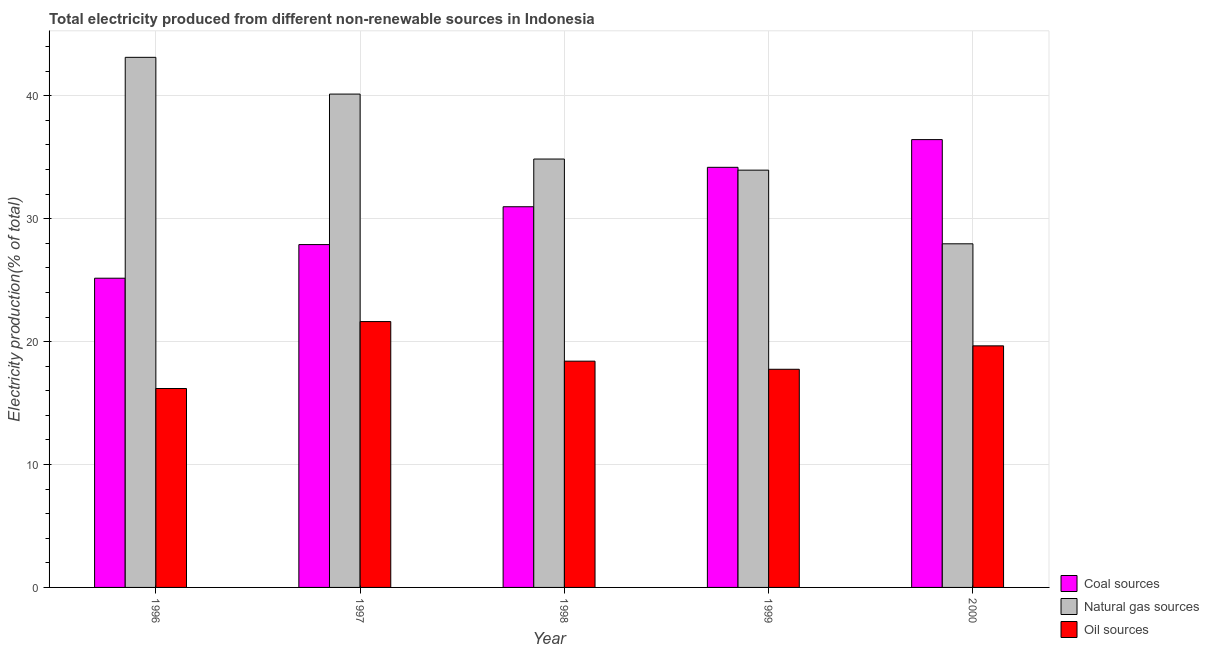Are the number of bars on each tick of the X-axis equal?
Make the answer very short. Yes. How many bars are there on the 1st tick from the right?
Offer a very short reply. 3. What is the percentage of electricity produced by oil sources in 1996?
Your response must be concise. 16.18. Across all years, what is the maximum percentage of electricity produced by natural gas?
Your answer should be very brief. 43.13. Across all years, what is the minimum percentage of electricity produced by oil sources?
Your response must be concise. 16.18. In which year was the percentage of electricity produced by coal maximum?
Your answer should be very brief. 2000. What is the total percentage of electricity produced by coal in the graph?
Give a very brief answer. 154.64. What is the difference between the percentage of electricity produced by natural gas in 1996 and that in 1997?
Provide a short and direct response. 2.99. What is the difference between the percentage of electricity produced by coal in 1999 and the percentage of electricity produced by natural gas in 1996?
Give a very brief answer. 9.02. What is the average percentage of electricity produced by coal per year?
Provide a short and direct response. 30.93. What is the ratio of the percentage of electricity produced by oil sources in 1996 to that in 1998?
Offer a terse response. 0.88. Is the percentage of electricity produced by natural gas in 1997 less than that in 1999?
Offer a very short reply. No. Is the difference between the percentage of electricity produced by oil sources in 1996 and 2000 greater than the difference between the percentage of electricity produced by natural gas in 1996 and 2000?
Provide a short and direct response. No. What is the difference between the highest and the second highest percentage of electricity produced by coal?
Ensure brevity in your answer.  2.25. What is the difference between the highest and the lowest percentage of electricity produced by coal?
Keep it short and to the point. 11.28. What does the 2nd bar from the left in 2000 represents?
Ensure brevity in your answer.  Natural gas sources. What does the 3rd bar from the right in 2000 represents?
Provide a succinct answer. Coal sources. Is it the case that in every year, the sum of the percentage of electricity produced by coal and percentage of electricity produced by natural gas is greater than the percentage of electricity produced by oil sources?
Ensure brevity in your answer.  Yes. Are all the bars in the graph horizontal?
Your answer should be very brief. No. How many years are there in the graph?
Give a very brief answer. 5. What is the difference between two consecutive major ticks on the Y-axis?
Give a very brief answer. 10. Are the values on the major ticks of Y-axis written in scientific E-notation?
Give a very brief answer. No. Does the graph contain grids?
Provide a succinct answer. Yes. What is the title of the graph?
Offer a terse response. Total electricity produced from different non-renewable sources in Indonesia. Does "Other sectors" appear as one of the legend labels in the graph?
Offer a terse response. No. What is the Electricity production(% of total) in Coal sources in 1996?
Your answer should be compact. 25.16. What is the Electricity production(% of total) of Natural gas sources in 1996?
Provide a succinct answer. 43.13. What is the Electricity production(% of total) in Oil sources in 1996?
Offer a very short reply. 16.18. What is the Electricity production(% of total) of Coal sources in 1997?
Keep it short and to the point. 27.89. What is the Electricity production(% of total) in Natural gas sources in 1997?
Give a very brief answer. 40.14. What is the Electricity production(% of total) of Oil sources in 1997?
Ensure brevity in your answer.  21.63. What is the Electricity production(% of total) of Coal sources in 1998?
Ensure brevity in your answer.  30.97. What is the Electricity production(% of total) in Natural gas sources in 1998?
Your answer should be compact. 34.85. What is the Electricity production(% of total) of Oil sources in 1998?
Your response must be concise. 18.41. What is the Electricity production(% of total) in Coal sources in 1999?
Your response must be concise. 34.18. What is the Electricity production(% of total) of Natural gas sources in 1999?
Offer a terse response. 33.95. What is the Electricity production(% of total) in Oil sources in 1999?
Your response must be concise. 17.75. What is the Electricity production(% of total) of Coal sources in 2000?
Offer a terse response. 36.43. What is the Electricity production(% of total) of Natural gas sources in 2000?
Make the answer very short. 27.96. What is the Electricity production(% of total) in Oil sources in 2000?
Your response must be concise. 19.65. Across all years, what is the maximum Electricity production(% of total) of Coal sources?
Provide a succinct answer. 36.43. Across all years, what is the maximum Electricity production(% of total) in Natural gas sources?
Offer a terse response. 43.13. Across all years, what is the maximum Electricity production(% of total) in Oil sources?
Keep it short and to the point. 21.63. Across all years, what is the minimum Electricity production(% of total) in Coal sources?
Offer a terse response. 25.16. Across all years, what is the minimum Electricity production(% of total) in Natural gas sources?
Ensure brevity in your answer.  27.96. Across all years, what is the minimum Electricity production(% of total) of Oil sources?
Provide a succinct answer. 16.18. What is the total Electricity production(% of total) of Coal sources in the graph?
Give a very brief answer. 154.64. What is the total Electricity production(% of total) of Natural gas sources in the graph?
Give a very brief answer. 180.02. What is the total Electricity production(% of total) of Oil sources in the graph?
Ensure brevity in your answer.  93.63. What is the difference between the Electricity production(% of total) of Coal sources in 1996 and that in 1997?
Provide a short and direct response. -2.74. What is the difference between the Electricity production(% of total) of Natural gas sources in 1996 and that in 1997?
Give a very brief answer. 2.99. What is the difference between the Electricity production(% of total) in Oil sources in 1996 and that in 1997?
Make the answer very short. -5.45. What is the difference between the Electricity production(% of total) in Coal sources in 1996 and that in 1998?
Keep it short and to the point. -5.81. What is the difference between the Electricity production(% of total) of Natural gas sources in 1996 and that in 1998?
Provide a succinct answer. 8.27. What is the difference between the Electricity production(% of total) in Oil sources in 1996 and that in 1998?
Give a very brief answer. -2.23. What is the difference between the Electricity production(% of total) in Coal sources in 1996 and that in 1999?
Ensure brevity in your answer.  -9.02. What is the difference between the Electricity production(% of total) in Natural gas sources in 1996 and that in 1999?
Your response must be concise. 9.18. What is the difference between the Electricity production(% of total) in Oil sources in 1996 and that in 1999?
Your answer should be compact. -1.57. What is the difference between the Electricity production(% of total) of Coal sources in 1996 and that in 2000?
Your answer should be very brief. -11.28. What is the difference between the Electricity production(% of total) in Natural gas sources in 1996 and that in 2000?
Your response must be concise. 15.17. What is the difference between the Electricity production(% of total) of Oil sources in 1996 and that in 2000?
Make the answer very short. -3.47. What is the difference between the Electricity production(% of total) of Coal sources in 1997 and that in 1998?
Make the answer very short. -3.08. What is the difference between the Electricity production(% of total) in Natural gas sources in 1997 and that in 1998?
Keep it short and to the point. 5.28. What is the difference between the Electricity production(% of total) of Oil sources in 1997 and that in 1998?
Your answer should be very brief. 3.22. What is the difference between the Electricity production(% of total) in Coal sources in 1997 and that in 1999?
Keep it short and to the point. -6.29. What is the difference between the Electricity production(% of total) in Natural gas sources in 1997 and that in 1999?
Provide a short and direct response. 6.19. What is the difference between the Electricity production(% of total) in Oil sources in 1997 and that in 1999?
Your answer should be very brief. 3.88. What is the difference between the Electricity production(% of total) of Coal sources in 1997 and that in 2000?
Keep it short and to the point. -8.54. What is the difference between the Electricity production(% of total) of Natural gas sources in 1997 and that in 2000?
Make the answer very short. 12.18. What is the difference between the Electricity production(% of total) of Oil sources in 1997 and that in 2000?
Ensure brevity in your answer.  1.98. What is the difference between the Electricity production(% of total) of Coal sources in 1998 and that in 1999?
Your answer should be compact. -3.21. What is the difference between the Electricity production(% of total) in Natural gas sources in 1998 and that in 1999?
Ensure brevity in your answer.  0.9. What is the difference between the Electricity production(% of total) in Oil sources in 1998 and that in 1999?
Your answer should be very brief. 0.66. What is the difference between the Electricity production(% of total) in Coal sources in 1998 and that in 2000?
Provide a short and direct response. -5.46. What is the difference between the Electricity production(% of total) in Natural gas sources in 1998 and that in 2000?
Provide a short and direct response. 6.9. What is the difference between the Electricity production(% of total) in Oil sources in 1998 and that in 2000?
Your response must be concise. -1.24. What is the difference between the Electricity production(% of total) of Coal sources in 1999 and that in 2000?
Provide a short and direct response. -2.25. What is the difference between the Electricity production(% of total) of Natural gas sources in 1999 and that in 2000?
Your answer should be very brief. 5.99. What is the difference between the Electricity production(% of total) of Oil sources in 1999 and that in 2000?
Give a very brief answer. -1.91. What is the difference between the Electricity production(% of total) in Coal sources in 1996 and the Electricity production(% of total) in Natural gas sources in 1997?
Provide a succinct answer. -14.98. What is the difference between the Electricity production(% of total) in Coal sources in 1996 and the Electricity production(% of total) in Oil sources in 1997?
Offer a very short reply. 3.53. What is the difference between the Electricity production(% of total) of Natural gas sources in 1996 and the Electricity production(% of total) of Oil sources in 1997?
Provide a succinct answer. 21.5. What is the difference between the Electricity production(% of total) in Coal sources in 1996 and the Electricity production(% of total) in Natural gas sources in 1998?
Provide a short and direct response. -9.7. What is the difference between the Electricity production(% of total) of Coal sources in 1996 and the Electricity production(% of total) of Oil sources in 1998?
Your response must be concise. 6.75. What is the difference between the Electricity production(% of total) of Natural gas sources in 1996 and the Electricity production(% of total) of Oil sources in 1998?
Provide a short and direct response. 24.72. What is the difference between the Electricity production(% of total) of Coal sources in 1996 and the Electricity production(% of total) of Natural gas sources in 1999?
Your answer should be very brief. -8.79. What is the difference between the Electricity production(% of total) in Coal sources in 1996 and the Electricity production(% of total) in Oil sources in 1999?
Your answer should be compact. 7.41. What is the difference between the Electricity production(% of total) of Natural gas sources in 1996 and the Electricity production(% of total) of Oil sources in 1999?
Give a very brief answer. 25.38. What is the difference between the Electricity production(% of total) of Coal sources in 1996 and the Electricity production(% of total) of Natural gas sources in 2000?
Make the answer very short. -2.8. What is the difference between the Electricity production(% of total) of Coal sources in 1996 and the Electricity production(% of total) of Oil sources in 2000?
Provide a succinct answer. 5.5. What is the difference between the Electricity production(% of total) in Natural gas sources in 1996 and the Electricity production(% of total) in Oil sources in 2000?
Provide a succinct answer. 23.47. What is the difference between the Electricity production(% of total) in Coal sources in 1997 and the Electricity production(% of total) in Natural gas sources in 1998?
Keep it short and to the point. -6.96. What is the difference between the Electricity production(% of total) in Coal sources in 1997 and the Electricity production(% of total) in Oil sources in 1998?
Provide a succinct answer. 9.48. What is the difference between the Electricity production(% of total) in Natural gas sources in 1997 and the Electricity production(% of total) in Oil sources in 1998?
Your answer should be very brief. 21.73. What is the difference between the Electricity production(% of total) in Coal sources in 1997 and the Electricity production(% of total) in Natural gas sources in 1999?
Your response must be concise. -6.06. What is the difference between the Electricity production(% of total) in Coal sources in 1997 and the Electricity production(% of total) in Oil sources in 1999?
Your answer should be compact. 10.14. What is the difference between the Electricity production(% of total) of Natural gas sources in 1997 and the Electricity production(% of total) of Oil sources in 1999?
Ensure brevity in your answer.  22.39. What is the difference between the Electricity production(% of total) in Coal sources in 1997 and the Electricity production(% of total) in Natural gas sources in 2000?
Your answer should be compact. -0.06. What is the difference between the Electricity production(% of total) in Coal sources in 1997 and the Electricity production(% of total) in Oil sources in 2000?
Make the answer very short. 8.24. What is the difference between the Electricity production(% of total) of Natural gas sources in 1997 and the Electricity production(% of total) of Oil sources in 2000?
Provide a short and direct response. 20.48. What is the difference between the Electricity production(% of total) of Coal sources in 1998 and the Electricity production(% of total) of Natural gas sources in 1999?
Provide a short and direct response. -2.98. What is the difference between the Electricity production(% of total) of Coal sources in 1998 and the Electricity production(% of total) of Oil sources in 1999?
Give a very brief answer. 13.22. What is the difference between the Electricity production(% of total) in Natural gas sources in 1998 and the Electricity production(% of total) in Oil sources in 1999?
Ensure brevity in your answer.  17.1. What is the difference between the Electricity production(% of total) in Coal sources in 1998 and the Electricity production(% of total) in Natural gas sources in 2000?
Ensure brevity in your answer.  3.02. What is the difference between the Electricity production(% of total) of Coal sources in 1998 and the Electricity production(% of total) of Oil sources in 2000?
Offer a very short reply. 11.32. What is the difference between the Electricity production(% of total) of Natural gas sources in 1998 and the Electricity production(% of total) of Oil sources in 2000?
Give a very brief answer. 15.2. What is the difference between the Electricity production(% of total) of Coal sources in 1999 and the Electricity production(% of total) of Natural gas sources in 2000?
Make the answer very short. 6.22. What is the difference between the Electricity production(% of total) in Coal sources in 1999 and the Electricity production(% of total) in Oil sources in 2000?
Your answer should be compact. 14.53. What is the difference between the Electricity production(% of total) of Natural gas sources in 1999 and the Electricity production(% of total) of Oil sources in 2000?
Your answer should be compact. 14.29. What is the average Electricity production(% of total) in Coal sources per year?
Offer a terse response. 30.93. What is the average Electricity production(% of total) of Natural gas sources per year?
Ensure brevity in your answer.  36. What is the average Electricity production(% of total) in Oil sources per year?
Provide a short and direct response. 18.73. In the year 1996, what is the difference between the Electricity production(% of total) of Coal sources and Electricity production(% of total) of Natural gas sources?
Your answer should be very brief. -17.97. In the year 1996, what is the difference between the Electricity production(% of total) in Coal sources and Electricity production(% of total) in Oil sources?
Give a very brief answer. 8.97. In the year 1996, what is the difference between the Electricity production(% of total) of Natural gas sources and Electricity production(% of total) of Oil sources?
Provide a short and direct response. 26.94. In the year 1997, what is the difference between the Electricity production(% of total) in Coal sources and Electricity production(% of total) in Natural gas sources?
Provide a short and direct response. -12.24. In the year 1997, what is the difference between the Electricity production(% of total) of Coal sources and Electricity production(% of total) of Oil sources?
Give a very brief answer. 6.26. In the year 1997, what is the difference between the Electricity production(% of total) in Natural gas sources and Electricity production(% of total) in Oil sources?
Ensure brevity in your answer.  18.51. In the year 1998, what is the difference between the Electricity production(% of total) in Coal sources and Electricity production(% of total) in Natural gas sources?
Give a very brief answer. -3.88. In the year 1998, what is the difference between the Electricity production(% of total) in Coal sources and Electricity production(% of total) in Oil sources?
Give a very brief answer. 12.56. In the year 1998, what is the difference between the Electricity production(% of total) in Natural gas sources and Electricity production(% of total) in Oil sources?
Provide a succinct answer. 16.44. In the year 1999, what is the difference between the Electricity production(% of total) of Coal sources and Electricity production(% of total) of Natural gas sources?
Provide a short and direct response. 0.23. In the year 1999, what is the difference between the Electricity production(% of total) of Coal sources and Electricity production(% of total) of Oil sources?
Provide a short and direct response. 16.43. In the year 1999, what is the difference between the Electricity production(% of total) of Natural gas sources and Electricity production(% of total) of Oil sources?
Provide a succinct answer. 16.2. In the year 2000, what is the difference between the Electricity production(% of total) in Coal sources and Electricity production(% of total) in Natural gas sources?
Provide a short and direct response. 8.48. In the year 2000, what is the difference between the Electricity production(% of total) in Coal sources and Electricity production(% of total) in Oil sources?
Ensure brevity in your answer.  16.78. In the year 2000, what is the difference between the Electricity production(% of total) of Natural gas sources and Electricity production(% of total) of Oil sources?
Offer a very short reply. 8.3. What is the ratio of the Electricity production(% of total) of Coal sources in 1996 to that in 1997?
Your answer should be very brief. 0.9. What is the ratio of the Electricity production(% of total) in Natural gas sources in 1996 to that in 1997?
Ensure brevity in your answer.  1.07. What is the ratio of the Electricity production(% of total) in Oil sources in 1996 to that in 1997?
Give a very brief answer. 0.75. What is the ratio of the Electricity production(% of total) of Coal sources in 1996 to that in 1998?
Keep it short and to the point. 0.81. What is the ratio of the Electricity production(% of total) in Natural gas sources in 1996 to that in 1998?
Give a very brief answer. 1.24. What is the ratio of the Electricity production(% of total) of Oil sources in 1996 to that in 1998?
Make the answer very short. 0.88. What is the ratio of the Electricity production(% of total) of Coal sources in 1996 to that in 1999?
Offer a terse response. 0.74. What is the ratio of the Electricity production(% of total) in Natural gas sources in 1996 to that in 1999?
Offer a terse response. 1.27. What is the ratio of the Electricity production(% of total) of Oil sources in 1996 to that in 1999?
Your response must be concise. 0.91. What is the ratio of the Electricity production(% of total) in Coal sources in 1996 to that in 2000?
Your response must be concise. 0.69. What is the ratio of the Electricity production(% of total) in Natural gas sources in 1996 to that in 2000?
Offer a terse response. 1.54. What is the ratio of the Electricity production(% of total) of Oil sources in 1996 to that in 2000?
Provide a short and direct response. 0.82. What is the ratio of the Electricity production(% of total) in Coal sources in 1997 to that in 1998?
Offer a terse response. 0.9. What is the ratio of the Electricity production(% of total) of Natural gas sources in 1997 to that in 1998?
Your answer should be compact. 1.15. What is the ratio of the Electricity production(% of total) of Oil sources in 1997 to that in 1998?
Offer a terse response. 1.18. What is the ratio of the Electricity production(% of total) in Coal sources in 1997 to that in 1999?
Your response must be concise. 0.82. What is the ratio of the Electricity production(% of total) in Natural gas sources in 1997 to that in 1999?
Make the answer very short. 1.18. What is the ratio of the Electricity production(% of total) of Oil sources in 1997 to that in 1999?
Your response must be concise. 1.22. What is the ratio of the Electricity production(% of total) of Coal sources in 1997 to that in 2000?
Your response must be concise. 0.77. What is the ratio of the Electricity production(% of total) in Natural gas sources in 1997 to that in 2000?
Make the answer very short. 1.44. What is the ratio of the Electricity production(% of total) of Oil sources in 1997 to that in 2000?
Make the answer very short. 1.1. What is the ratio of the Electricity production(% of total) of Coal sources in 1998 to that in 1999?
Your answer should be compact. 0.91. What is the ratio of the Electricity production(% of total) of Natural gas sources in 1998 to that in 1999?
Offer a very short reply. 1.03. What is the ratio of the Electricity production(% of total) in Oil sources in 1998 to that in 1999?
Give a very brief answer. 1.04. What is the ratio of the Electricity production(% of total) of Coal sources in 1998 to that in 2000?
Provide a short and direct response. 0.85. What is the ratio of the Electricity production(% of total) in Natural gas sources in 1998 to that in 2000?
Offer a very short reply. 1.25. What is the ratio of the Electricity production(% of total) of Oil sources in 1998 to that in 2000?
Provide a short and direct response. 0.94. What is the ratio of the Electricity production(% of total) in Coal sources in 1999 to that in 2000?
Your response must be concise. 0.94. What is the ratio of the Electricity production(% of total) of Natural gas sources in 1999 to that in 2000?
Keep it short and to the point. 1.21. What is the ratio of the Electricity production(% of total) in Oil sources in 1999 to that in 2000?
Ensure brevity in your answer.  0.9. What is the difference between the highest and the second highest Electricity production(% of total) of Coal sources?
Provide a short and direct response. 2.25. What is the difference between the highest and the second highest Electricity production(% of total) in Natural gas sources?
Offer a terse response. 2.99. What is the difference between the highest and the second highest Electricity production(% of total) of Oil sources?
Ensure brevity in your answer.  1.98. What is the difference between the highest and the lowest Electricity production(% of total) in Coal sources?
Give a very brief answer. 11.28. What is the difference between the highest and the lowest Electricity production(% of total) in Natural gas sources?
Your response must be concise. 15.17. What is the difference between the highest and the lowest Electricity production(% of total) of Oil sources?
Offer a very short reply. 5.45. 